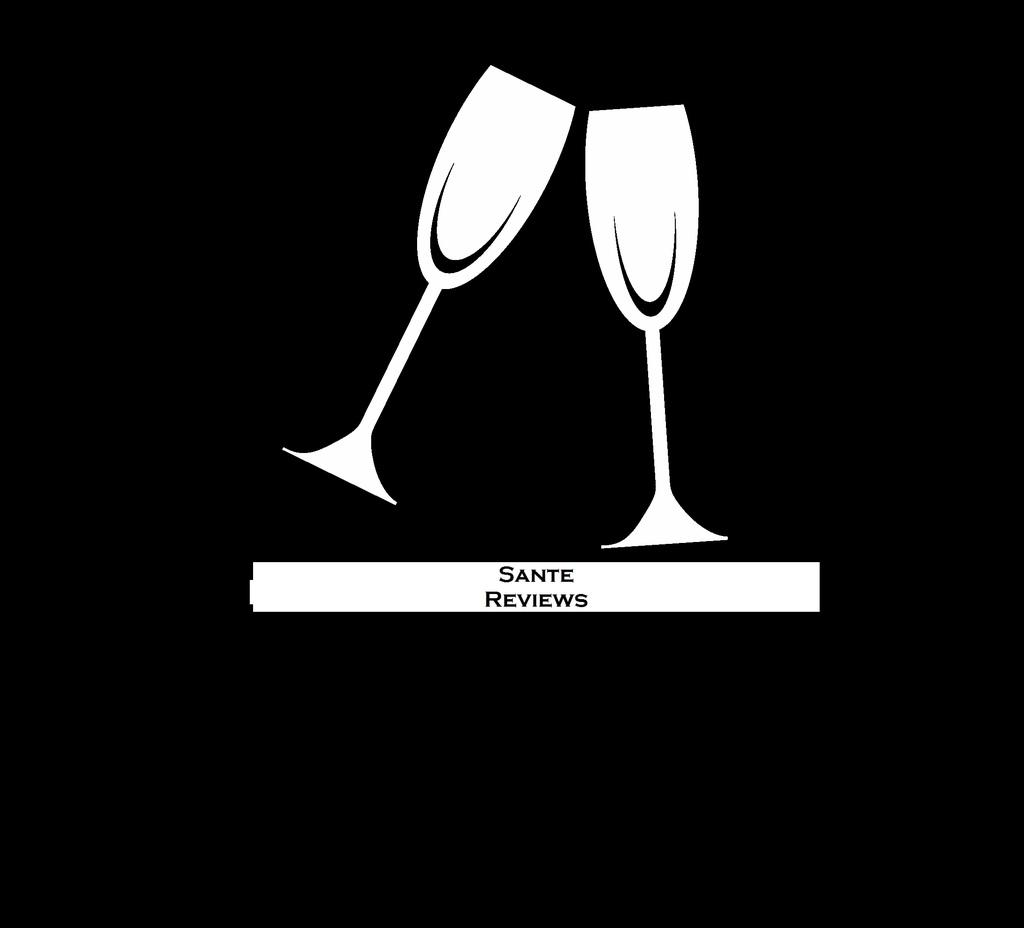What is depicted in the picture? The picture contains graphical images of glasses. What else can be found in the picture? There is text under the glasses in the picture. How many yards of fabric were used to create the sea in the image? There is no sea depicted in the image; it only contains graphical images of glasses and text. 